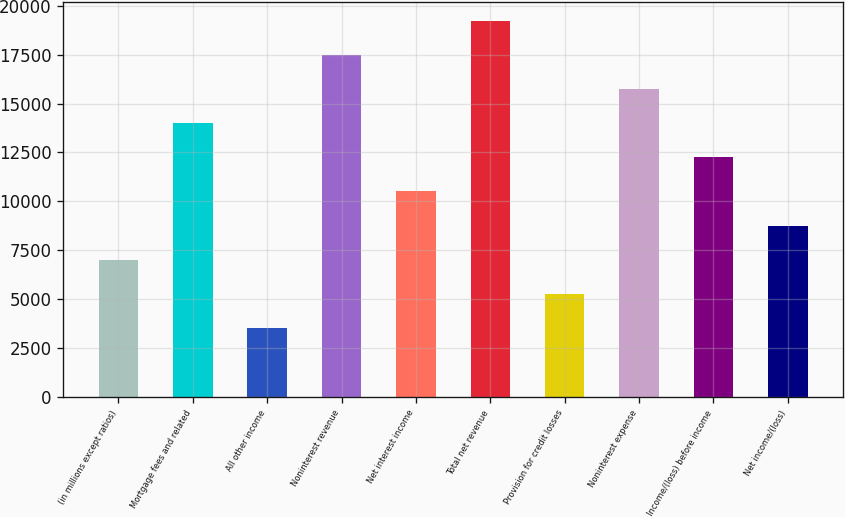<chart> <loc_0><loc_0><loc_500><loc_500><bar_chart><fcel>(in millions except ratios)<fcel>Mortgage fees and related<fcel>All other income<fcel>Noninterest revenue<fcel>Net interest income<fcel>Total net revenue<fcel>Provision for credit losses<fcel>Noninterest expense<fcel>Income/(loss) before income<fcel>Net income/(loss)<nl><fcel>7011.4<fcel>14003.8<fcel>3515.2<fcel>17500<fcel>10507.6<fcel>19248.1<fcel>5263.3<fcel>15751.9<fcel>12255.7<fcel>8759.5<nl></chart> 